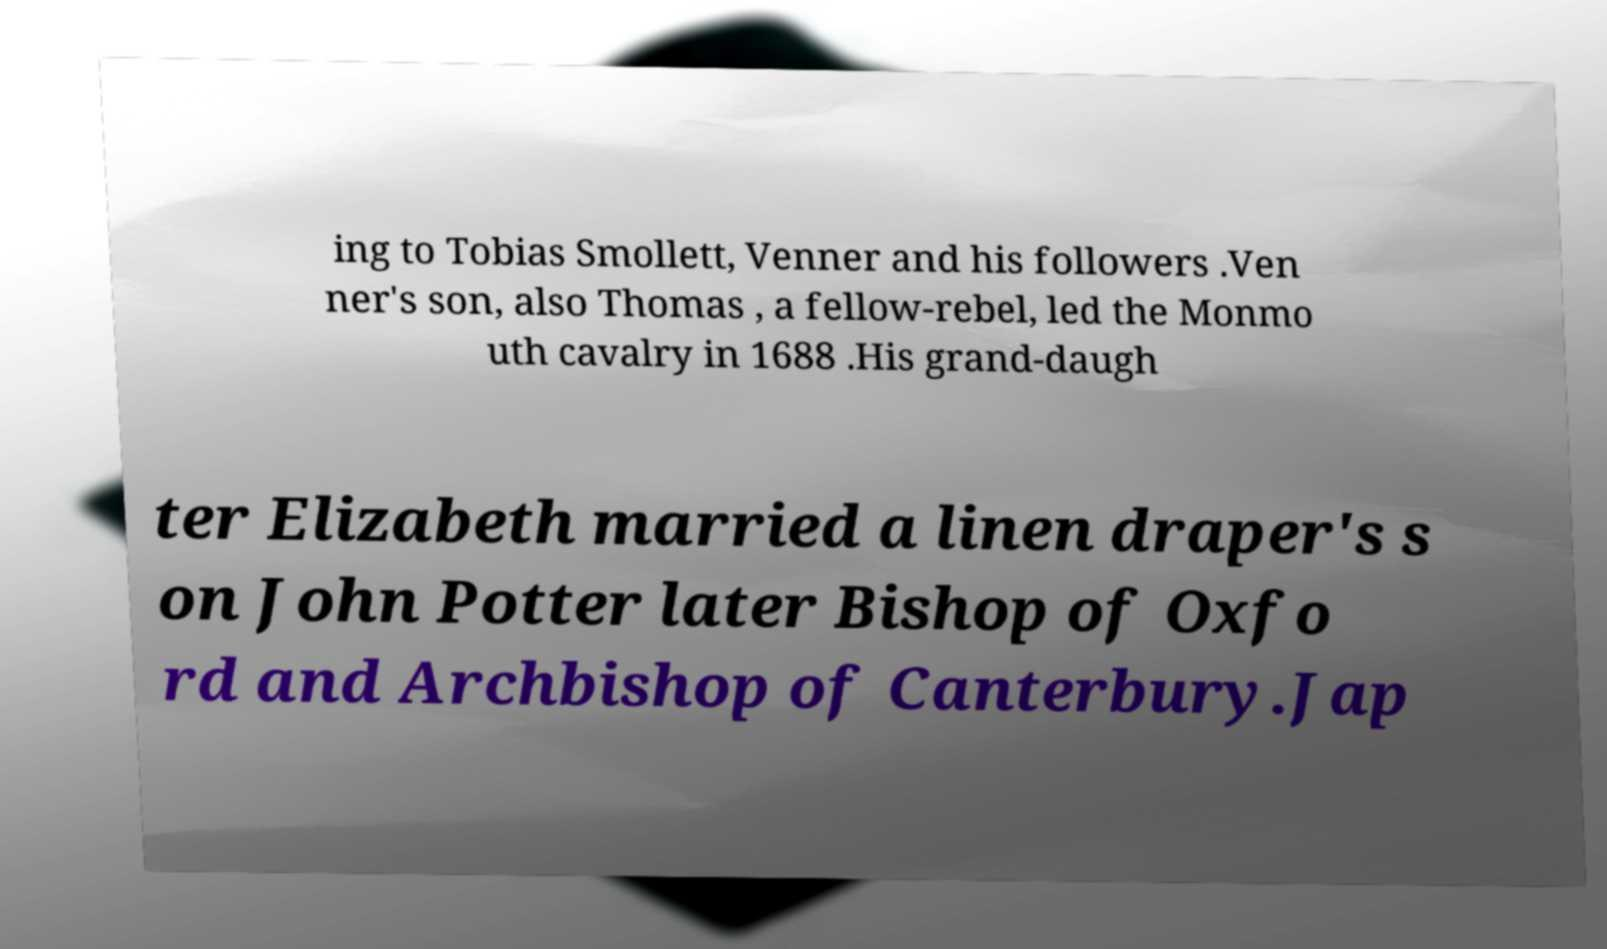For documentation purposes, I need the text within this image transcribed. Could you provide that? ing to Tobias Smollett, Venner and his followers .Ven ner's son, also Thomas , a fellow-rebel, led the Monmo uth cavalry in 1688 .His grand-daugh ter Elizabeth married a linen draper's s on John Potter later Bishop of Oxfo rd and Archbishop of Canterbury.Jap 